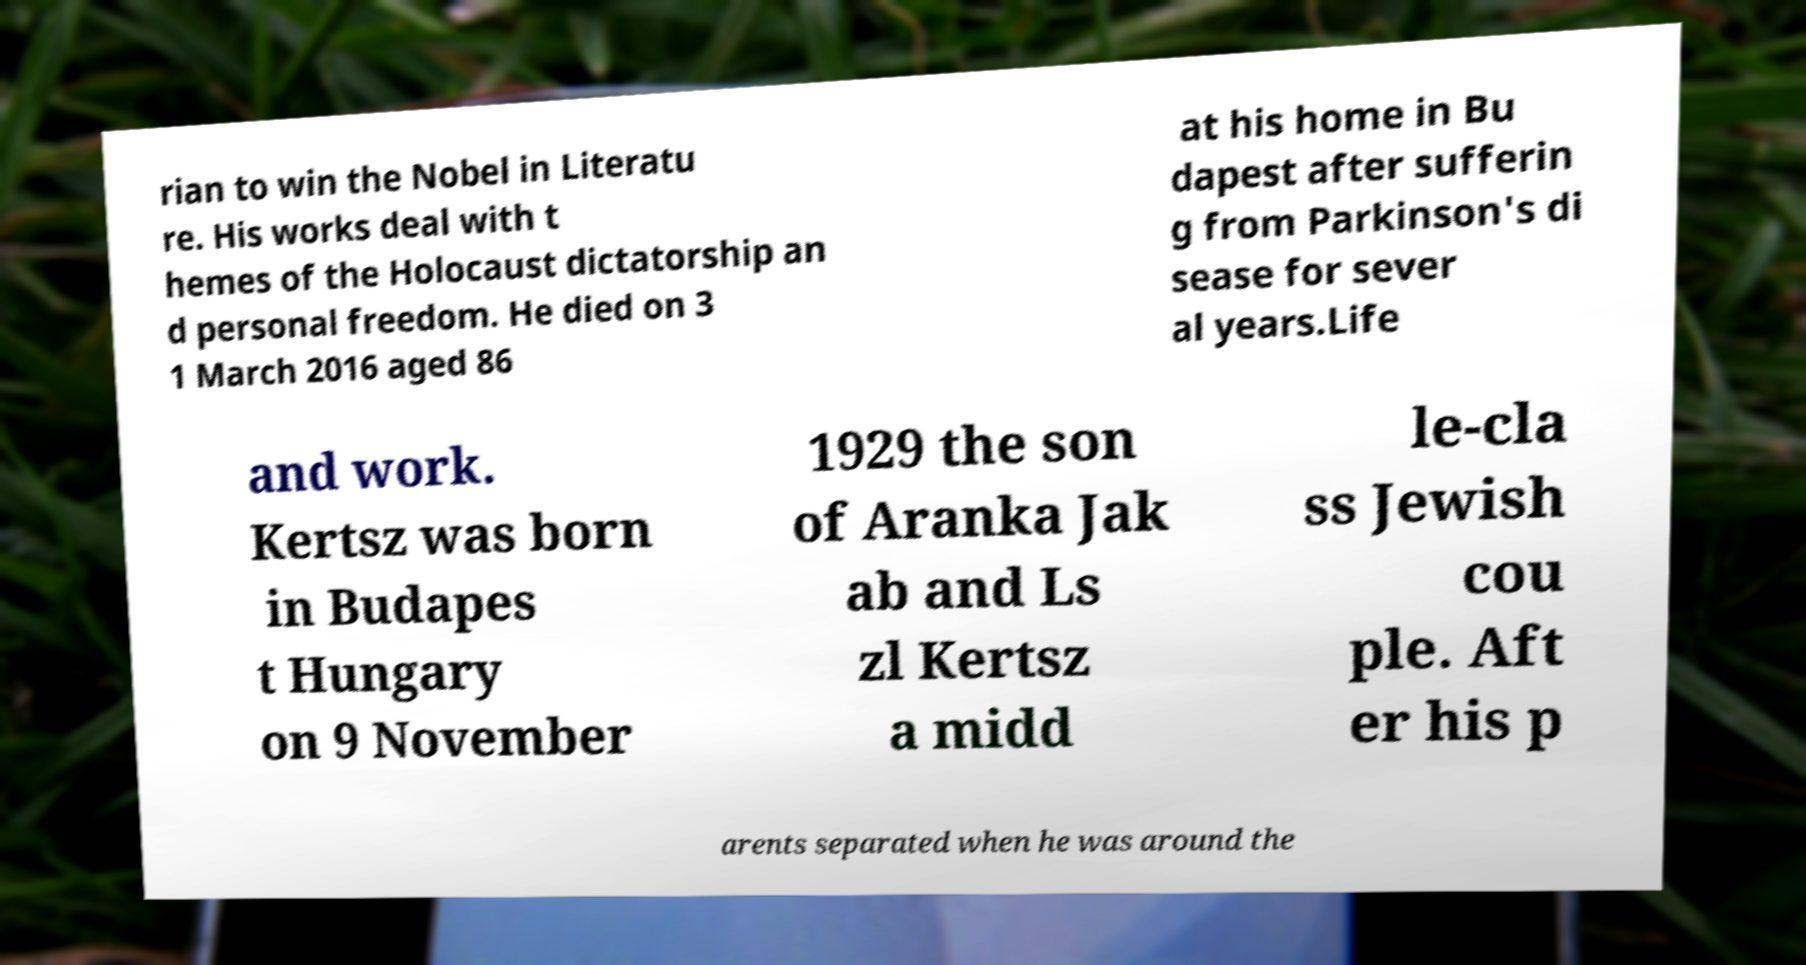What messages or text are displayed in this image? I need them in a readable, typed format. rian to win the Nobel in Literatu re. His works deal with t hemes of the Holocaust dictatorship an d personal freedom. He died on 3 1 March 2016 aged 86 at his home in Bu dapest after sufferin g from Parkinson's di sease for sever al years.Life and work. Kertsz was born in Budapes t Hungary on 9 November 1929 the son of Aranka Jak ab and Ls zl Kertsz a midd le-cla ss Jewish cou ple. Aft er his p arents separated when he was around the 